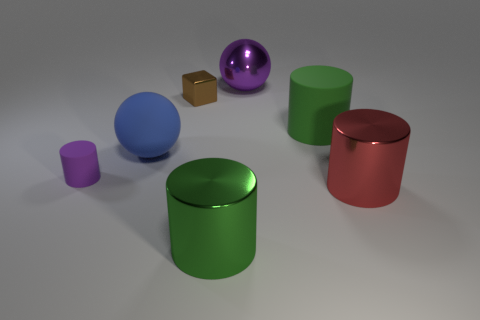Add 1 small blue cylinders. How many objects exist? 8 Subtract all cubes. How many objects are left? 6 Add 5 small gray shiny cubes. How many small gray shiny cubes exist? 5 Subtract 0 green cubes. How many objects are left? 7 Subtract all large purple shiny spheres. Subtract all big green matte things. How many objects are left? 5 Add 2 small metallic blocks. How many small metallic blocks are left? 3 